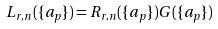Convert formula to latex. <formula><loc_0><loc_0><loc_500><loc_500>L _ { r , n } ( \{ a _ { p } \} ) = R _ { r , n } ( \{ a _ { p } \} ) G ( \{ a _ { p } \} )</formula> 